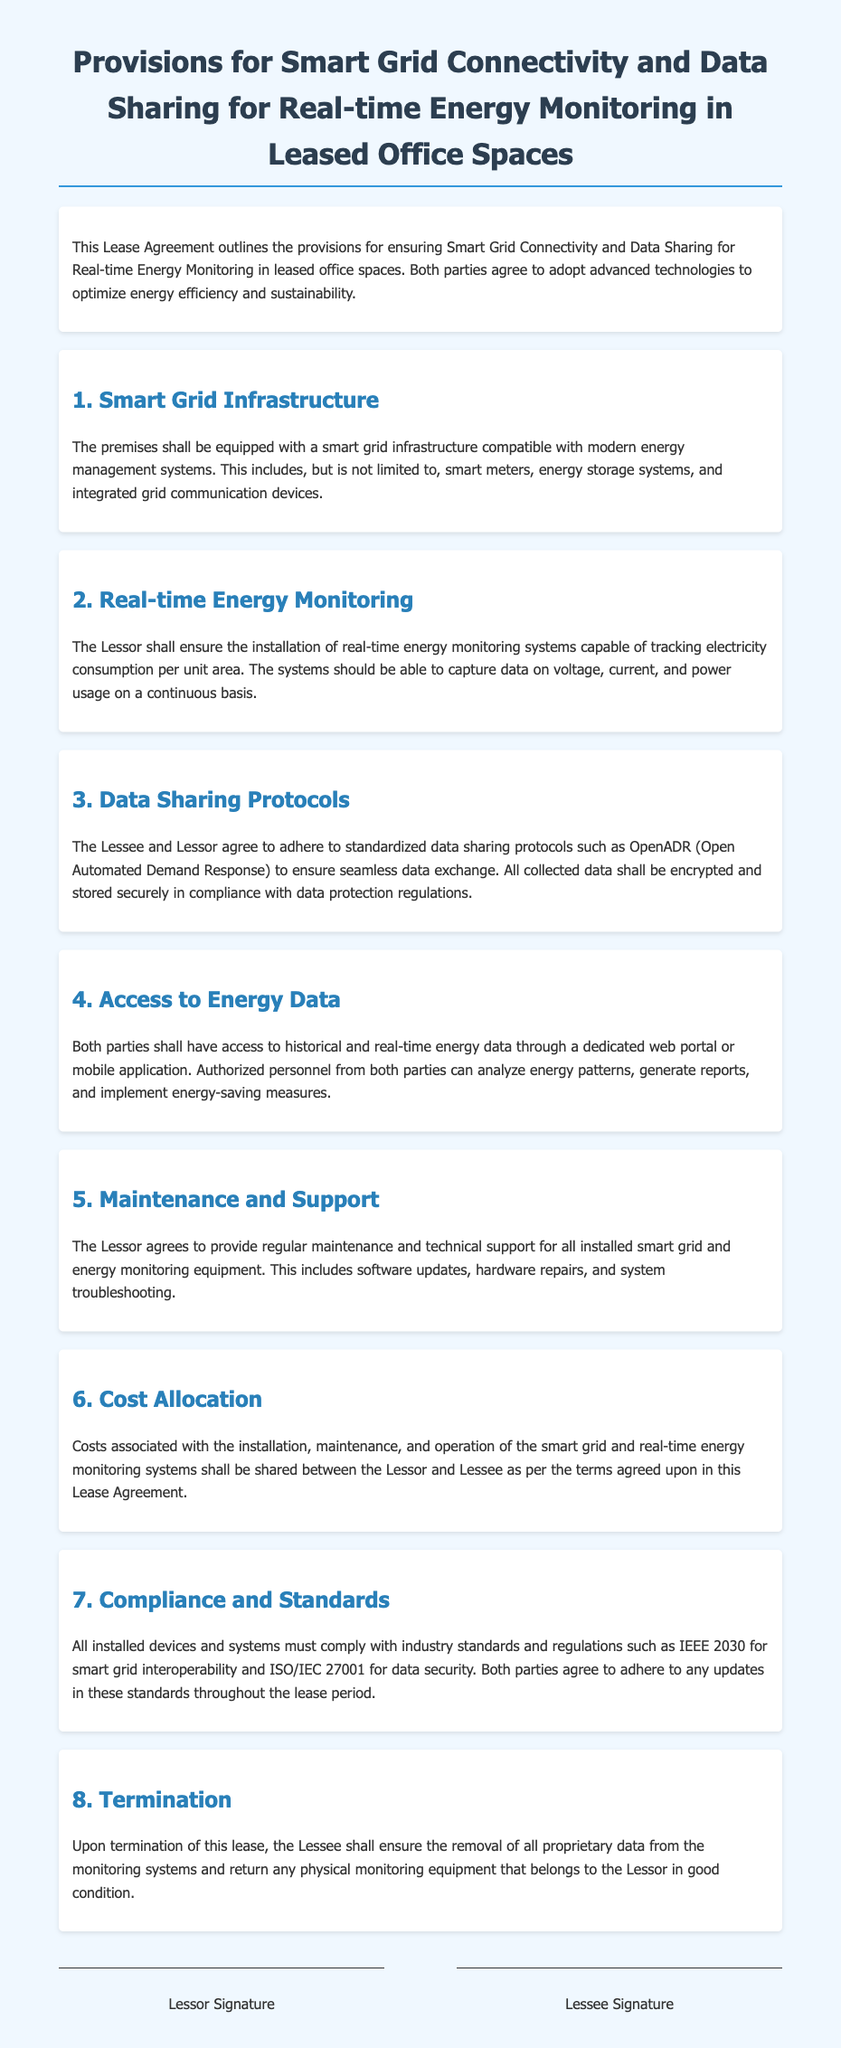What is the title of the document? The title of the document is specified at the top and summarizes the content related to smart grid connectivity and data sharing for leased office spaces.
Answer: Provisions for Smart Grid Connectivity and Data Sharing for Real-time Energy Monitoring in Leased Office Spaces Who is responsible for ensuring real-time energy monitoring systems are installed? The document states that the Lessor is responsible for ensuring the installation of these systems.
Answer: Lessor What data sharing protocol is mentioned in the document? The document explicitly refers to OpenADR as the standardized data sharing protocol to be adhered to by both parties.
Answer: OpenADR What industry standard must all installed devices comply with? The document specifies that devices must comply with IEEE 2030 for smart grid interoperability.
Answer: IEEE 2030 What shall happen upon termination of the lease? The document outlines that the Lessee must remove proprietary data and return physical monitoring equipment in good condition.
Answer: Remove proprietary data How will costs for the smart grid systems be allocated? The document indicates that costs for installation, maintenance, and operation will be shared according to terms in the agreement.
Answer: Shared between Lessor and Lessee What is the main purpose of the smart grid infrastructure mentioned? The smart grid infrastructure is specifically described as being compatible with modern energy management systems to optimize energy efficiency.
Answer: Optimize energy efficiency What maintenance obligations does the Lessor have? The document states that the Lessor agrees to provide regular maintenance and technical support for all installed systems and equipment.
Answer: Regular maintenance and technical support 